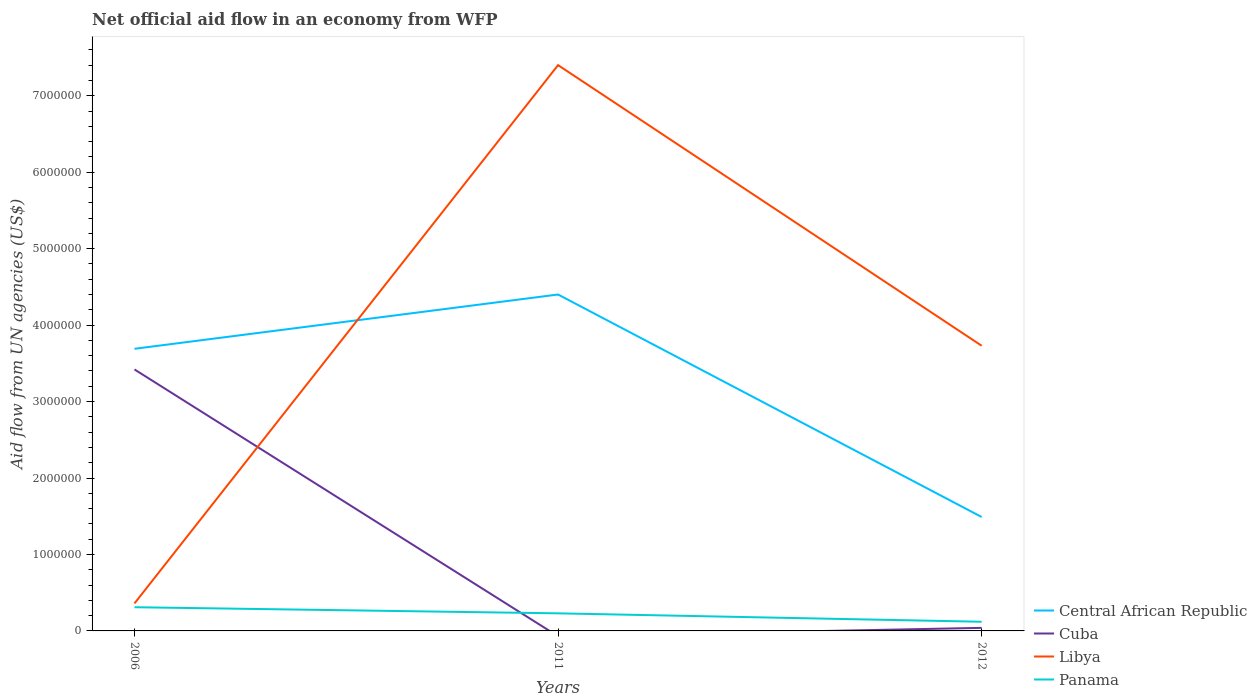How many different coloured lines are there?
Your answer should be compact. 4. What is the total net official aid flow in Central African Republic in the graph?
Provide a short and direct response. 2.91e+06. What is the difference between the highest and the second highest net official aid flow in Cuba?
Your response must be concise. 3.42e+06. What is the difference between the highest and the lowest net official aid flow in Central African Republic?
Your answer should be very brief. 2. Is the net official aid flow in Panama strictly greater than the net official aid flow in Cuba over the years?
Give a very brief answer. No. How many lines are there?
Offer a very short reply. 4. What is the difference between two consecutive major ticks on the Y-axis?
Your answer should be compact. 1.00e+06. Are the values on the major ticks of Y-axis written in scientific E-notation?
Offer a terse response. No. Does the graph contain any zero values?
Ensure brevity in your answer.  Yes. Does the graph contain grids?
Your answer should be compact. No. Where does the legend appear in the graph?
Give a very brief answer. Bottom right. What is the title of the graph?
Make the answer very short. Net official aid flow in an economy from WFP. Does "Marshall Islands" appear as one of the legend labels in the graph?
Offer a terse response. No. What is the label or title of the X-axis?
Offer a very short reply. Years. What is the label or title of the Y-axis?
Offer a very short reply. Aid flow from UN agencies (US$). What is the Aid flow from UN agencies (US$) of Central African Republic in 2006?
Keep it short and to the point. 3.69e+06. What is the Aid flow from UN agencies (US$) in Cuba in 2006?
Your answer should be very brief. 3.42e+06. What is the Aid flow from UN agencies (US$) in Central African Republic in 2011?
Your answer should be very brief. 4.40e+06. What is the Aid flow from UN agencies (US$) of Libya in 2011?
Keep it short and to the point. 7.40e+06. What is the Aid flow from UN agencies (US$) of Panama in 2011?
Provide a succinct answer. 2.30e+05. What is the Aid flow from UN agencies (US$) of Central African Republic in 2012?
Provide a short and direct response. 1.49e+06. What is the Aid flow from UN agencies (US$) of Libya in 2012?
Your answer should be very brief. 3.73e+06. Across all years, what is the maximum Aid flow from UN agencies (US$) in Central African Republic?
Provide a short and direct response. 4.40e+06. Across all years, what is the maximum Aid flow from UN agencies (US$) of Cuba?
Offer a terse response. 3.42e+06. Across all years, what is the maximum Aid flow from UN agencies (US$) in Libya?
Offer a very short reply. 7.40e+06. Across all years, what is the maximum Aid flow from UN agencies (US$) of Panama?
Ensure brevity in your answer.  3.10e+05. Across all years, what is the minimum Aid flow from UN agencies (US$) in Central African Republic?
Provide a succinct answer. 1.49e+06. Across all years, what is the minimum Aid flow from UN agencies (US$) in Cuba?
Your response must be concise. 0. Across all years, what is the minimum Aid flow from UN agencies (US$) in Libya?
Keep it short and to the point. 3.60e+05. Across all years, what is the minimum Aid flow from UN agencies (US$) in Panama?
Give a very brief answer. 1.20e+05. What is the total Aid flow from UN agencies (US$) of Central African Republic in the graph?
Your answer should be compact. 9.58e+06. What is the total Aid flow from UN agencies (US$) in Cuba in the graph?
Make the answer very short. 3.46e+06. What is the total Aid flow from UN agencies (US$) in Libya in the graph?
Offer a terse response. 1.15e+07. What is the total Aid flow from UN agencies (US$) in Panama in the graph?
Your answer should be compact. 6.60e+05. What is the difference between the Aid flow from UN agencies (US$) in Central African Republic in 2006 and that in 2011?
Make the answer very short. -7.10e+05. What is the difference between the Aid flow from UN agencies (US$) of Libya in 2006 and that in 2011?
Keep it short and to the point. -7.04e+06. What is the difference between the Aid flow from UN agencies (US$) of Central African Republic in 2006 and that in 2012?
Your answer should be very brief. 2.20e+06. What is the difference between the Aid flow from UN agencies (US$) in Cuba in 2006 and that in 2012?
Make the answer very short. 3.38e+06. What is the difference between the Aid flow from UN agencies (US$) in Libya in 2006 and that in 2012?
Make the answer very short. -3.37e+06. What is the difference between the Aid flow from UN agencies (US$) of Panama in 2006 and that in 2012?
Make the answer very short. 1.90e+05. What is the difference between the Aid flow from UN agencies (US$) in Central African Republic in 2011 and that in 2012?
Keep it short and to the point. 2.91e+06. What is the difference between the Aid flow from UN agencies (US$) of Libya in 2011 and that in 2012?
Provide a succinct answer. 3.67e+06. What is the difference between the Aid flow from UN agencies (US$) of Panama in 2011 and that in 2012?
Give a very brief answer. 1.10e+05. What is the difference between the Aid flow from UN agencies (US$) of Central African Republic in 2006 and the Aid flow from UN agencies (US$) of Libya in 2011?
Your answer should be compact. -3.71e+06. What is the difference between the Aid flow from UN agencies (US$) in Central African Republic in 2006 and the Aid flow from UN agencies (US$) in Panama in 2011?
Give a very brief answer. 3.46e+06. What is the difference between the Aid flow from UN agencies (US$) of Cuba in 2006 and the Aid flow from UN agencies (US$) of Libya in 2011?
Give a very brief answer. -3.98e+06. What is the difference between the Aid flow from UN agencies (US$) of Cuba in 2006 and the Aid flow from UN agencies (US$) of Panama in 2011?
Give a very brief answer. 3.19e+06. What is the difference between the Aid flow from UN agencies (US$) of Libya in 2006 and the Aid flow from UN agencies (US$) of Panama in 2011?
Your response must be concise. 1.30e+05. What is the difference between the Aid flow from UN agencies (US$) of Central African Republic in 2006 and the Aid flow from UN agencies (US$) of Cuba in 2012?
Provide a succinct answer. 3.65e+06. What is the difference between the Aid flow from UN agencies (US$) of Central African Republic in 2006 and the Aid flow from UN agencies (US$) of Libya in 2012?
Offer a very short reply. -4.00e+04. What is the difference between the Aid flow from UN agencies (US$) of Central African Republic in 2006 and the Aid flow from UN agencies (US$) of Panama in 2012?
Your answer should be very brief. 3.57e+06. What is the difference between the Aid flow from UN agencies (US$) in Cuba in 2006 and the Aid flow from UN agencies (US$) in Libya in 2012?
Your answer should be very brief. -3.10e+05. What is the difference between the Aid flow from UN agencies (US$) in Cuba in 2006 and the Aid flow from UN agencies (US$) in Panama in 2012?
Offer a terse response. 3.30e+06. What is the difference between the Aid flow from UN agencies (US$) in Libya in 2006 and the Aid flow from UN agencies (US$) in Panama in 2012?
Offer a very short reply. 2.40e+05. What is the difference between the Aid flow from UN agencies (US$) of Central African Republic in 2011 and the Aid flow from UN agencies (US$) of Cuba in 2012?
Provide a succinct answer. 4.36e+06. What is the difference between the Aid flow from UN agencies (US$) in Central African Republic in 2011 and the Aid flow from UN agencies (US$) in Libya in 2012?
Provide a short and direct response. 6.70e+05. What is the difference between the Aid flow from UN agencies (US$) in Central African Republic in 2011 and the Aid flow from UN agencies (US$) in Panama in 2012?
Offer a terse response. 4.28e+06. What is the difference between the Aid flow from UN agencies (US$) in Libya in 2011 and the Aid flow from UN agencies (US$) in Panama in 2012?
Ensure brevity in your answer.  7.28e+06. What is the average Aid flow from UN agencies (US$) in Central African Republic per year?
Give a very brief answer. 3.19e+06. What is the average Aid flow from UN agencies (US$) in Cuba per year?
Your response must be concise. 1.15e+06. What is the average Aid flow from UN agencies (US$) in Libya per year?
Make the answer very short. 3.83e+06. What is the average Aid flow from UN agencies (US$) of Panama per year?
Provide a short and direct response. 2.20e+05. In the year 2006, what is the difference between the Aid flow from UN agencies (US$) in Central African Republic and Aid flow from UN agencies (US$) in Libya?
Offer a very short reply. 3.33e+06. In the year 2006, what is the difference between the Aid flow from UN agencies (US$) of Central African Republic and Aid flow from UN agencies (US$) of Panama?
Offer a very short reply. 3.38e+06. In the year 2006, what is the difference between the Aid flow from UN agencies (US$) of Cuba and Aid flow from UN agencies (US$) of Libya?
Give a very brief answer. 3.06e+06. In the year 2006, what is the difference between the Aid flow from UN agencies (US$) of Cuba and Aid flow from UN agencies (US$) of Panama?
Keep it short and to the point. 3.11e+06. In the year 2011, what is the difference between the Aid flow from UN agencies (US$) in Central African Republic and Aid flow from UN agencies (US$) in Libya?
Offer a very short reply. -3.00e+06. In the year 2011, what is the difference between the Aid flow from UN agencies (US$) of Central African Republic and Aid flow from UN agencies (US$) of Panama?
Provide a short and direct response. 4.17e+06. In the year 2011, what is the difference between the Aid flow from UN agencies (US$) of Libya and Aid flow from UN agencies (US$) of Panama?
Make the answer very short. 7.17e+06. In the year 2012, what is the difference between the Aid flow from UN agencies (US$) of Central African Republic and Aid flow from UN agencies (US$) of Cuba?
Provide a succinct answer. 1.45e+06. In the year 2012, what is the difference between the Aid flow from UN agencies (US$) in Central African Republic and Aid flow from UN agencies (US$) in Libya?
Ensure brevity in your answer.  -2.24e+06. In the year 2012, what is the difference between the Aid flow from UN agencies (US$) of Central African Republic and Aid flow from UN agencies (US$) of Panama?
Provide a short and direct response. 1.37e+06. In the year 2012, what is the difference between the Aid flow from UN agencies (US$) of Cuba and Aid flow from UN agencies (US$) of Libya?
Ensure brevity in your answer.  -3.69e+06. In the year 2012, what is the difference between the Aid flow from UN agencies (US$) of Libya and Aid flow from UN agencies (US$) of Panama?
Keep it short and to the point. 3.61e+06. What is the ratio of the Aid flow from UN agencies (US$) of Central African Republic in 2006 to that in 2011?
Ensure brevity in your answer.  0.84. What is the ratio of the Aid flow from UN agencies (US$) of Libya in 2006 to that in 2011?
Provide a short and direct response. 0.05. What is the ratio of the Aid flow from UN agencies (US$) of Panama in 2006 to that in 2011?
Provide a short and direct response. 1.35. What is the ratio of the Aid flow from UN agencies (US$) in Central African Republic in 2006 to that in 2012?
Keep it short and to the point. 2.48. What is the ratio of the Aid flow from UN agencies (US$) of Cuba in 2006 to that in 2012?
Ensure brevity in your answer.  85.5. What is the ratio of the Aid flow from UN agencies (US$) in Libya in 2006 to that in 2012?
Your response must be concise. 0.1. What is the ratio of the Aid flow from UN agencies (US$) of Panama in 2006 to that in 2012?
Your answer should be very brief. 2.58. What is the ratio of the Aid flow from UN agencies (US$) in Central African Republic in 2011 to that in 2012?
Your response must be concise. 2.95. What is the ratio of the Aid flow from UN agencies (US$) in Libya in 2011 to that in 2012?
Give a very brief answer. 1.98. What is the ratio of the Aid flow from UN agencies (US$) of Panama in 2011 to that in 2012?
Your answer should be compact. 1.92. What is the difference between the highest and the second highest Aid flow from UN agencies (US$) of Central African Republic?
Keep it short and to the point. 7.10e+05. What is the difference between the highest and the second highest Aid flow from UN agencies (US$) in Libya?
Provide a succinct answer. 3.67e+06. What is the difference between the highest and the lowest Aid flow from UN agencies (US$) of Central African Republic?
Your answer should be compact. 2.91e+06. What is the difference between the highest and the lowest Aid flow from UN agencies (US$) of Cuba?
Keep it short and to the point. 3.42e+06. What is the difference between the highest and the lowest Aid flow from UN agencies (US$) in Libya?
Ensure brevity in your answer.  7.04e+06. What is the difference between the highest and the lowest Aid flow from UN agencies (US$) in Panama?
Give a very brief answer. 1.90e+05. 